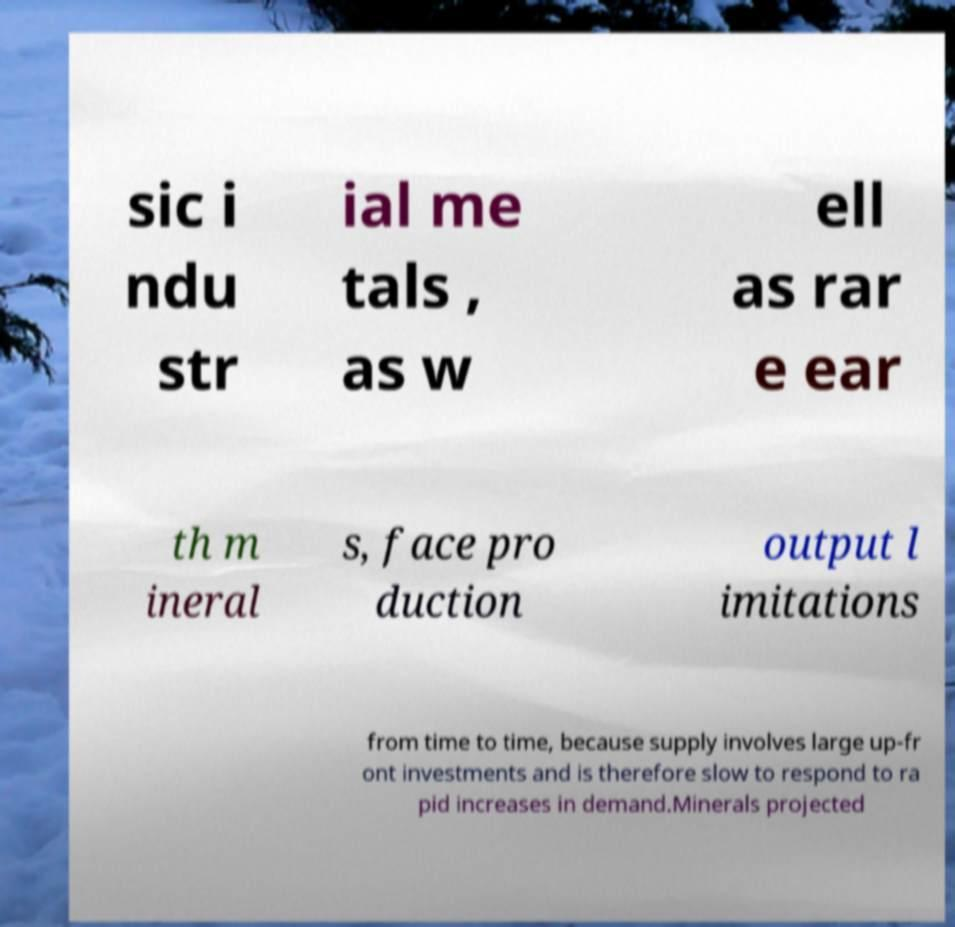Please identify and transcribe the text found in this image. sic i ndu str ial me tals , as w ell as rar e ear th m ineral s, face pro duction output l imitations from time to time, because supply involves large up-fr ont investments and is therefore slow to respond to ra pid increases in demand.Minerals projected 